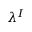Convert formula to latex. <formula><loc_0><loc_0><loc_500><loc_500>\lambda ^ { I }</formula> 